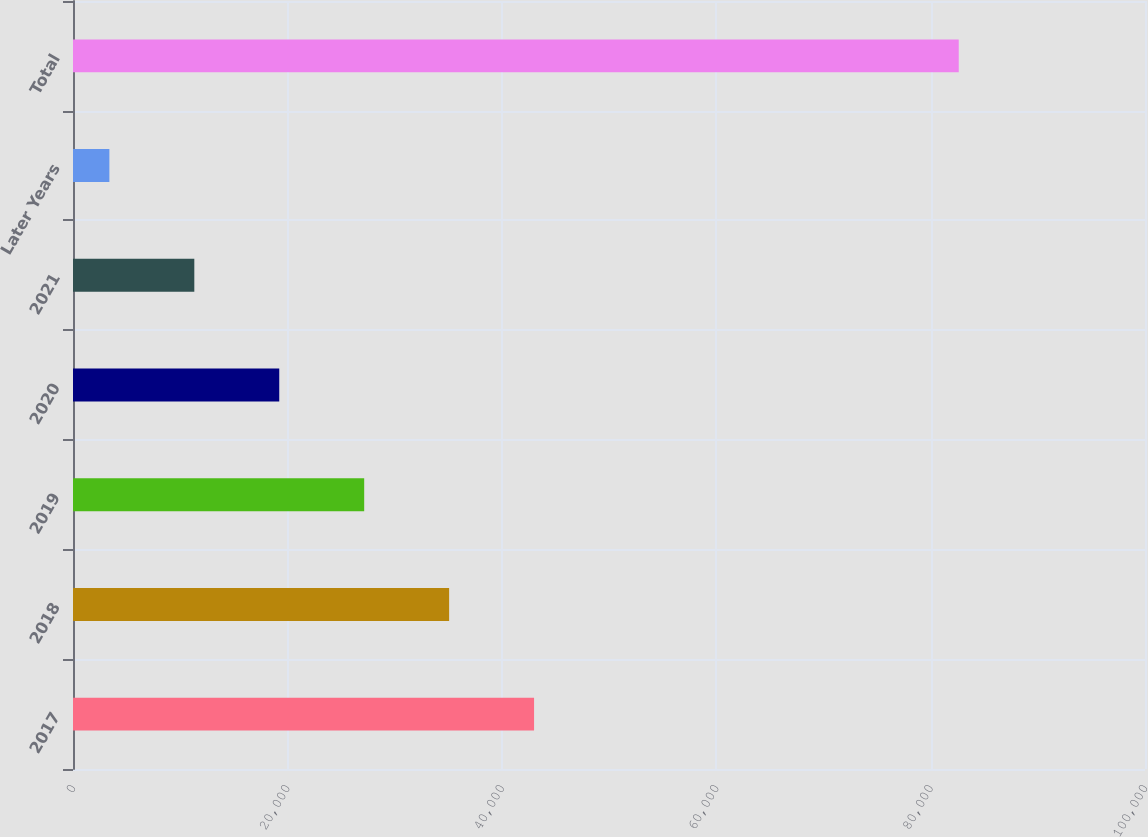Convert chart. <chart><loc_0><loc_0><loc_500><loc_500><bar_chart><fcel>2017<fcel>2018<fcel>2019<fcel>2020<fcel>2021<fcel>Later Years<fcel>Total<nl><fcel>43009.5<fcel>35086.4<fcel>27163.3<fcel>19240.2<fcel>11317.1<fcel>3394<fcel>82625<nl></chart> 